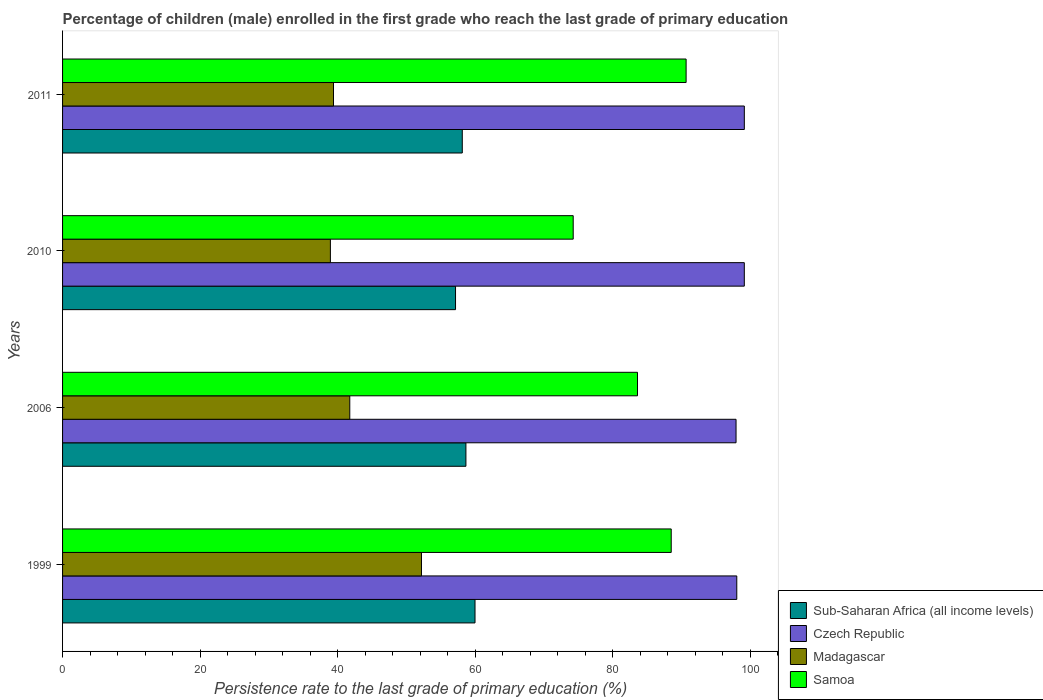How many different coloured bars are there?
Give a very brief answer. 4. How many groups of bars are there?
Provide a succinct answer. 4. Are the number of bars per tick equal to the number of legend labels?
Ensure brevity in your answer.  Yes. How many bars are there on the 3rd tick from the top?
Your answer should be compact. 4. How many bars are there on the 4th tick from the bottom?
Provide a succinct answer. 4. What is the label of the 2nd group of bars from the top?
Give a very brief answer. 2010. In how many cases, is the number of bars for a given year not equal to the number of legend labels?
Keep it short and to the point. 0. What is the persistence rate of children in Czech Republic in 2010?
Provide a short and direct response. 99.13. Across all years, what is the maximum persistence rate of children in Madagascar?
Your response must be concise. 52.19. Across all years, what is the minimum persistence rate of children in Samoa?
Your answer should be very brief. 74.25. In which year was the persistence rate of children in Sub-Saharan Africa (all income levels) minimum?
Give a very brief answer. 2010. What is the total persistence rate of children in Sub-Saharan Africa (all income levels) in the graph?
Provide a succinct answer. 233.87. What is the difference between the persistence rate of children in Madagascar in 2006 and that in 2011?
Your answer should be very brief. 2.37. What is the difference between the persistence rate of children in Madagascar in 2011 and the persistence rate of children in Czech Republic in 1999?
Your answer should be compact. -58.64. What is the average persistence rate of children in Czech Republic per year?
Offer a terse response. 98.55. In the year 2011, what is the difference between the persistence rate of children in Madagascar and persistence rate of children in Samoa?
Provide a succinct answer. -51.27. What is the ratio of the persistence rate of children in Samoa in 2006 to that in 2011?
Offer a terse response. 0.92. What is the difference between the highest and the second highest persistence rate of children in Madagascar?
Keep it short and to the point. 10.43. What is the difference between the highest and the lowest persistence rate of children in Samoa?
Provide a succinct answer. 16.42. What does the 1st bar from the top in 2006 represents?
Your answer should be compact. Samoa. What does the 2nd bar from the bottom in 1999 represents?
Your answer should be very brief. Czech Republic. Is it the case that in every year, the sum of the persistence rate of children in Madagascar and persistence rate of children in Sub-Saharan Africa (all income levels) is greater than the persistence rate of children in Samoa?
Offer a terse response. Yes. How many bars are there?
Keep it short and to the point. 16. Are all the bars in the graph horizontal?
Offer a very short reply. Yes. Does the graph contain any zero values?
Ensure brevity in your answer.  No. Where does the legend appear in the graph?
Give a very brief answer. Bottom right. How are the legend labels stacked?
Provide a short and direct response. Vertical. What is the title of the graph?
Provide a short and direct response. Percentage of children (male) enrolled in the first grade who reach the last grade of primary education. Does "Libya" appear as one of the legend labels in the graph?
Your answer should be very brief. No. What is the label or title of the X-axis?
Give a very brief answer. Persistence rate to the last grade of primary education (%). What is the Persistence rate to the last grade of primary education (%) of Sub-Saharan Africa (all income levels) in 1999?
Provide a succinct answer. 59.97. What is the Persistence rate to the last grade of primary education (%) in Czech Republic in 1999?
Offer a very short reply. 98.03. What is the Persistence rate to the last grade of primary education (%) of Madagascar in 1999?
Provide a short and direct response. 52.19. What is the Persistence rate to the last grade of primary education (%) in Samoa in 1999?
Provide a short and direct response. 88.5. What is the Persistence rate to the last grade of primary education (%) of Sub-Saharan Africa (all income levels) in 2006?
Provide a succinct answer. 58.65. What is the Persistence rate to the last grade of primary education (%) of Czech Republic in 2006?
Provide a short and direct response. 97.92. What is the Persistence rate to the last grade of primary education (%) of Madagascar in 2006?
Keep it short and to the point. 41.76. What is the Persistence rate to the last grade of primary education (%) of Samoa in 2006?
Your answer should be very brief. 83.59. What is the Persistence rate to the last grade of primary education (%) of Sub-Saharan Africa (all income levels) in 2010?
Provide a short and direct response. 57.14. What is the Persistence rate to the last grade of primary education (%) of Czech Republic in 2010?
Offer a very short reply. 99.13. What is the Persistence rate to the last grade of primary education (%) of Madagascar in 2010?
Keep it short and to the point. 38.94. What is the Persistence rate to the last grade of primary education (%) of Samoa in 2010?
Your response must be concise. 74.25. What is the Persistence rate to the last grade of primary education (%) of Sub-Saharan Africa (all income levels) in 2011?
Give a very brief answer. 58.12. What is the Persistence rate to the last grade of primary education (%) of Czech Republic in 2011?
Offer a terse response. 99.13. What is the Persistence rate to the last grade of primary education (%) in Madagascar in 2011?
Make the answer very short. 39.39. What is the Persistence rate to the last grade of primary education (%) of Samoa in 2011?
Your response must be concise. 90.66. Across all years, what is the maximum Persistence rate to the last grade of primary education (%) in Sub-Saharan Africa (all income levels)?
Your answer should be very brief. 59.97. Across all years, what is the maximum Persistence rate to the last grade of primary education (%) of Czech Republic?
Offer a terse response. 99.13. Across all years, what is the maximum Persistence rate to the last grade of primary education (%) in Madagascar?
Your answer should be very brief. 52.19. Across all years, what is the maximum Persistence rate to the last grade of primary education (%) of Samoa?
Give a very brief answer. 90.66. Across all years, what is the minimum Persistence rate to the last grade of primary education (%) of Sub-Saharan Africa (all income levels)?
Make the answer very short. 57.14. Across all years, what is the minimum Persistence rate to the last grade of primary education (%) in Czech Republic?
Give a very brief answer. 97.92. Across all years, what is the minimum Persistence rate to the last grade of primary education (%) of Madagascar?
Offer a very short reply. 38.94. Across all years, what is the minimum Persistence rate to the last grade of primary education (%) in Samoa?
Your response must be concise. 74.25. What is the total Persistence rate to the last grade of primary education (%) in Sub-Saharan Africa (all income levels) in the graph?
Ensure brevity in your answer.  233.87. What is the total Persistence rate to the last grade of primary education (%) in Czech Republic in the graph?
Make the answer very short. 394.2. What is the total Persistence rate to the last grade of primary education (%) of Madagascar in the graph?
Make the answer very short. 172.28. What is the total Persistence rate to the last grade of primary education (%) of Samoa in the graph?
Your answer should be very brief. 337. What is the difference between the Persistence rate to the last grade of primary education (%) of Sub-Saharan Africa (all income levels) in 1999 and that in 2006?
Your response must be concise. 1.32. What is the difference between the Persistence rate to the last grade of primary education (%) in Czech Republic in 1999 and that in 2006?
Your response must be concise. 0.11. What is the difference between the Persistence rate to the last grade of primary education (%) in Madagascar in 1999 and that in 2006?
Give a very brief answer. 10.43. What is the difference between the Persistence rate to the last grade of primary education (%) of Samoa in 1999 and that in 2006?
Provide a short and direct response. 4.9. What is the difference between the Persistence rate to the last grade of primary education (%) of Sub-Saharan Africa (all income levels) in 1999 and that in 2010?
Ensure brevity in your answer.  2.83. What is the difference between the Persistence rate to the last grade of primary education (%) in Czech Republic in 1999 and that in 2010?
Keep it short and to the point. -1.1. What is the difference between the Persistence rate to the last grade of primary education (%) in Madagascar in 1999 and that in 2010?
Your answer should be very brief. 13.25. What is the difference between the Persistence rate to the last grade of primary education (%) of Samoa in 1999 and that in 2010?
Make the answer very short. 14.25. What is the difference between the Persistence rate to the last grade of primary education (%) in Sub-Saharan Africa (all income levels) in 1999 and that in 2011?
Provide a short and direct response. 1.85. What is the difference between the Persistence rate to the last grade of primary education (%) in Czech Republic in 1999 and that in 2011?
Provide a succinct answer. -1.1. What is the difference between the Persistence rate to the last grade of primary education (%) of Madagascar in 1999 and that in 2011?
Offer a terse response. 12.79. What is the difference between the Persistence rate to the last grade of primary education (%) in Samoa in 1999 and that in 2011?
Your answer should be very brief. -2.17. What is the difference between the Persistence rate to the last grade of primary education (%) in Sub-Saharan Africa (all income levels) in 2006 and that in 2010?
Give a very brief answer. 1.51. What is the difference between the Persistence rate to the last grade of primary education (%) of Czech Republic in 2006 and that in 2010?
Provide a short and direct response. -1.2. What is the difference between the Persistence rate to the last grade of primary education (%) in Madagascar in 2006 and that in 2010?
Your answer should be very brief. 2.82. What is the difference between the Persistence rate to the last grade of primary education (%) of Samoa in 2006 and that in 2010?
Your answer should be compact. 9.35. What is the difference between the Persistence rate to the last grade of primary education (%) of Sub-Saharan Africa (all income levels) in 2006 and that in 2011?
Your answer should be compact. 0.53. What is the difference between the Persistence rate to the last grade of primary education (%) of Czech Republic in 2006 and that in 2011?
Ensure brevity in your answer.  -1.2. What is the difference between the Persistence rate to the last grade of primary education (%) in Madagascar in 2006 and that in 2011?
Your answer should be very brief. 2.37. What is the difference between the Persistence rate to the last grade of primary education (%) of Samoa in 2006 and that in 2011?
Offer a terse response. -7.07. What is the difference between the Persistence rate to the last grade of primary education (%) in Sub-Saharan Africa (all income levels) in 2010 and that in 2011?
Ensure brevity in your answer.  -0.98. What is the difference between the Persistence rate to the last grade of primary education (%) in Czech Republic in 2010 and that in 2011?
Your answer should be compact. -0. What is the difference between the Persistence rate to the last grade of primary education (%) of Madagascar in 2010 and that in 2011?
Provide a short and direct response. -0.45. What is the difference between the Persistence rate to the last grade of primary education (%) of Samoa in 2010 and that in 2011?
Offer a terse response. -16.42. What is the difference between the Persistence rate to the last grade of primary education (%) of Sub-Saharan Africa (all income levels) in 1999 and the Persistence rate to the last grade of primary education (%) of Czech Republic in 2006?
Keep it short and to the point. -37.95. What is the difference between the Persistence rate to the last grade of primary education (%) in Sub-Saharan Africa (all income levels) in 1999 and the Persistence rate to the last grade of primary education (%) in Madagascar in 2006?
Offer a very short reply. 18.21. What is the difference between the Persistence rate to the last grade of primary education (%) in Sub-Saharan Africa (all income levels) in 1999 and the Persistence rate to the last grade of primary education (%) in Samoa in 2006?
Provide a short and direct response. -23.63. What is the difference between the Persistence rate to the last grade of primary education (%) of Czech Republic in 1999 and the Persistence rate to the last grade of primary education (%) of Madagascar in 2006?
Make the answer very short. 56.27. What is the difference between the Persistence rate to the last grade of primary education (%) in Czech Republic in 1999 and the Persistence rate to the last grade of primary education (%) in Samoa in 2006?
Offer a very short reply. 14.44. What is the difference between the Persistence rate to the last grade of primary education (%) in Madagascar in 1999 and the Persistence rate to the last grade of primary education (%) in Samoa in 2006?
Keep it short and to the point. -31.41. What is the difference between the Persistence rate to the last grade of primary education (%) of Sub-Saharan Africa (all income levels) in 1999 and the Persistence rate to the last grade of primary education (%) of Czech Republic in 2010?
Provide a succinct answer. -39.16. What is the difference between the Persistence rate to the last grade of primary education (%) of Sub-Saharan Africa (all income levels) in 1999 and the Persistence rate to the last grade of primary education (%) of Madagascar in 2010?
Keep it short and to the point. 21.03. What is the difference between the Persistence rate to the last grade of primary education (%) in Sub-Saharan Africa (all income levels) in 1999 and the Persistence rate to the last grade of primary education (%) in Samoa in 2010?
Provide a short and direct response. -14.28. What is the difference between the Persistence rate to the last grade of primary education (%) of Czech Republic in 1999 and the Persistence rate to the last grade of primary education (%) of Madagascar in 2010?
Your answer should be very brief. 59.09. What is the difference between the Persistence rate to the last grade of primary education (%) of Czech Republic in 1999 and the Persistence rate to the last grade of primary education (%) of Samoa in 2010?
Your answer should be compact. 23.78. What is the difference between the Persistence rate to the last grade of primary education (%) of Madagascar in 1999 and the Persistence rate to the last grade of primary education (%) of Samoa in 2010?
Make the answer very short. -22.06. What is the difference between the Persistence rate to the last grade of primary education (%) of Sub-Saharan Africa (all income levels) in 1999 and the Persistence rate to the last grade of primary education (%) of Czech Republic in 2011?
Your answer should be very brief. -39.16. What is the difference between the Persistence rate to the last grade of primary education (%) in Sub-Saharan Africa (all income levels) in 1999 and the Persistence rate to the last grade of primary education (%) in Madagascar in 2011?
Your answer should be very brief. 20.58. What is the difference between the Persistence rate to the last grade of primary education (%) in Sub-Saharan Africa (all income levels) in 1999 and the Persistence rate to the last grade of primary education (%) in Samoa in 2011?
Offer a terse response. -30.69. What is the difference between the Persistence rate to the last grade of primary education (%) in Czech Republic in 1999 and the Persistence rate to the last grade of primary education (%) in Madagascar in 2011?
Provide a short and direct response. 58.64. What is the difference between the Persistence rate to the last grade of primary education (%) of Czech Republic in 1999 and the Persistence rate to the last grade of primary education (%) of Samoa in 2011?
Your answer should be very brief. 7.37. What is the difference between the Persistence rate to the last grade of primary education (%) of Madagascar in 1999 and the Persistence rate to the last grade of primary education (%) of Samoa in 2011?
Ensure brevity in your answer.  -38.48. What is the difference between the Persistence rate to the last grade of primary education (%) of Sub-Saharan Africa (all income levels) in 2006 and the Persistence rate to the last grade of primary education (%) of Czech Republic in 2010?
Make the answer very short. -40.48. What is the difference between the Persistence rate to the last grade of primary education (%) of Sub-Saharan Africa (all income levels) in 2006 and the Persistence rate to the last grade of primary education (%) of Madagascar in 2010?
Provide a short and direct response. 19.71. What is the difference between the Persistence rate to the last grade of primary education (%) in Sub-Saharan Africa (all income levels) in 2006 and the Persistence rate to the last grade of primary education (%) in Samoa in 2010?
Your answer should be compact. -15.6. What is the difference between the Persistence rate to the last grade of primary education (%) of Czech Republic in 2006 and the Persistence rate to the last grade of primary education (%) of Madagascar in 2010?
Ensure brevity in your answer.  58.98. What is the difference between the Persistence rate to the last grade of primary education (%) of Czech Republic in 2006 and the Persistence rate to the last grade of primary education (%) of Samoa in 2010?
Provide a short and direct response. 23.68. What is the difference between the Persistence rate to the last grade of primary education (%) of Madagascar in 2006 and the Persistence rate to the last grade of primary education (%) of Samoa in 2010?
Make the answer very short. -32.49. What is the difference between the Persistence rate to the last grade of primary education (%) of Sub-Saharan Africa (all income levels) in 2006 and the Persistence rate to the last grade of primary education (%) of Czech Republic in 2011?
Your response must be concise. -40.48. What is the difference between the Persistence rate to the last grade of primary education (%) of Sub-Saharan Africa (all income levels) in 2006 and the Persistence rate to the last grade of primary education (%) of Madagascar in 2011?
Ensure brevity in your answer.  19.26. What is the difference between the Persistence rate to the last grade of primary education (%) in Sub-Saharan Africa (all income levels) in 2006 and the Persistence rate to the last grade of primary education (%) in Samoa in 2011?
Keep it short and to the point. -32.02. What is the difference between the Persistence rate to the last grade of primary education (%) in Czech Republic in 2006 and the Persistence rate to the last grade of primary education (%) in Madagascar in 2011?
Your answer should be compact. 58.53. What is the difference between the Persistence rate to the last grade of primary education (%) in Czech Republic in 2006 and the Persistence rate to the last grade of primary education (%) in Samoa in 2011?
Offer a very short reply. 7.26. What is the difference between the Persistence rate to the last grade of primary education (%) in Madagascar in 2006 and the Persistence rate to the last grade of primary education (%) in Samoa in 2011?
Keep it short and to the point. -48.9. What is the difference between the Persistence rate to the last grade of primary education (%) in Sub-Saharan Africa (all income levels) in 2010 and the Persistence rate to the last grade of primary education (%) in Czech Republic in 2011?
Provide a short and direct response. -41.99. What is the difference between the Persistence rate to the last grade of primary education (%) in Sub-Saharan Africa (all income levels) in 2010 and the Persistence rate to the last grade of primary education (%) in Madagascar in 2011?
Provide a short and direct response. 17.74. What is the difference between the Persistence rate to the last grade of primary education (%) in Sub-Saharan Africa (all income levels) in 2010 and the Persistence rate to the last grade of primary education (%) in Samoa in 2011?
Make the answer very short. -33.53. What is the difference between the Persistence rate to the last grade of primary education (%) of Czech Republic in 2010 and the Persistence rate to the last grade of primary education (%) of Madagascar in 2011?
Your answer should be very brief. 59.73. What is the difference between the Persistence rate to the last grade of primary education (%) of Czech Republic in 2010 and the Persistence rate to the last grade of primary education (%) of Samoa in 2011?
Make the answer very short. 8.46. What is the difference between the Persistence rate to the last grade of primary education (%) of Madagascar in 2010 and the Persistence rate to the last grade of primary education (%) of Samoa in 2011?
Your response must be concise. -51.72. What is the average Persistence rate to the last grade of primary education (%) of Sub-Saharan Africa (all income levels) per year?
Give a very brief answer. 58.47. What is the average Persistence rate to the last grade of primary education (%) of Czech Republic per year?
Your response must be concise. 98.55. What is the average Persistence rate to the last grade of primary education (%) in Madagascar per year?
Offer a terse response. 43.07. What is the average Persistence rate to the last grade of primary education (%) of Samoa per year?
Keep it short and to the point. 84.25. In the year 1999, what is the difference between the Persistence rate to the last grade of primary education (%) of Sub-Saharan Africa (all income levels) and Persistence rate to the last grade of primary education (%) of Czech Republic?
Your answer should be very brief. -38.06. In the year 1999, what is the difference between the Persistence rate to the last grade of primary education (%) in Sub-Saharan Africa (all income levels) and Persistence rate to the last grade of primary education (%) in Madagascar?
Offer a very short reply. 7.78. In the year 1999, what is the difference between the Persistence rate to the last grade of primary education (%) of Sub-Saharan Africa (all income levels) and Persistence rate to the last grade of primary education (%) of Samoa?
Give a very brief answer. -28.53. In the year 1999, what is the difference between the Persistence rate to the last grade of primary education (%) in Czech Republic and Persistence rate to the last grade of primary education (%) in Madagascar?
Ensure brevity in your answer.  45.84. In the year 1999, what is the difference between the Persistence rate to the last grade of primary education (%) in Czech Republic and Persistence rate to the last grade of primary education (%) in Samoa?
Your response must be concise. 9.53. In the year 1999, what is the difference between the Persistence rate to the last grade of primary education (%) of Madagascar and Persistence rate to the last grade of primary education (%) of Samoa?
Offer a terse response. -36.31. In the year 2006, what is the difference between the Persistence rate to the last grade of primary education (%) in Sub-Saharan Africa (all income levels) and Persistence rate to the last grade of primary education (%) in Czech Republic?
Keep it short and to the point. -39.28. In the year 2006, what is the difference between the Persistence rate to the last grade of primary education (%) in Sub-Saharan Africa (all income levels) and Persistence rate to the last grade of primary education (%) in Madagascar?
Your answer should be compact. 16.89. In the year 2006, what is the difference between the Persistence rate to the last grade of primary education (%) in Sub-Saharan Africa (all income levels) and Persistence rate to the last grade of primary education (%) in Samoa?
Give a very brief answer. -24.95. In the year 2006, what is the difference between the Persistence rate to the last grade of primary education (%) of Czech Republic and Persistence rate to the last grade of primary education (%) of Madagascar?
Give a very brief answer. 56.16. In the year 2006, what is the difference between the Persistence rate to the last grade of primary education (%) of Czech Republic and Persistence rate to the last grade of primary education (%) of Samoa?
Make the answer very short. 14.33. In the year 2006, what is the difference between the Persistence rate to the last grade of primary education (%) of Madagascar and Persistence rate to the last grade of primary education (%) of Samoa?
Provide a short and direct response. -41.83. In the year 2010, what is the difference between the Persistence rate to the last grade of primary education (%) in Sub-Saharan Africa (all income levels) and Persistence rate to the last grade of primary education (%) in Czech Republic?
Keep it short and to the point. -41.99. In the year 2010, what is the difference between the Persistence rate to the last grade of primary education (%) in Sub-Saharan Africa (all income levels) and Persistence rate to the last grade of primary education (%) in Madagascar?
Keep it short and to the point. 18.2. In the year 2010, what is the difference between the Persistence rate to the last grade of primary education (%) of Sub-Saharan Africa (all income levels) and Persistence rate to the last grade of primary education (%) of Samoa?
Keep it short and to the point. -17.11. In the year 2010, what is the difference between the Persistence rate to the last grade of primary education (%) of Czech Republic and Persistence rate to the last grade of primary education (%) of Madagascar?
Keep it short and to the point. 60.18. In the year 2010, what is the difference between the Persistence rate to the last grade of primary education (%) of Czech Republic and Persistence rate to the last grade of primary education (%) of Samoa?
Your answer should be very brief. 24.88. In the year 2010, what is the difference between the Persistence rate to the last grade of primary education (%) of Madagascar and Persistence rate to the last grade of primary education (%) of Samoa?
Give a very brief answer. -35.3. In the year 2011, what is the difference between the Persistence rate to the last grade of primary education (%) of Sub-Saharan Africa (all income levels) and Persistence rate to the last grade of primary education (%) of Czech Republic?
Provide a short and direct response. -41.01. In the year 2011, what is the difference between the Persistence rate to the last grade of primary education (%) of Sub-Saharan Africa (all income levels) and Persistence rate to the last grade of primary education (%) of Madagascar?
Provide a succinct answer. 18.73. In the year 2011, what is the difference between the Persistence rate to the last grade of primary education (%) in Sub-Saharan Africa (all income levels) and Persistence rate to the last grade of primary education (%) in Samoa?
Ensure brevity in your answer.  -32.54. In the year 2011, what is the difference between the Persistence rate to the last grade of primary education (%) in Czech Republic and Persistence rate to the last grade of primary education (%) in Madagascar?
Your response must be concise. 59.73. In the year 2011, what is the difference between the Persistence rate to the last grade of primary education (%) of Czech Republic and Persistence rate to the last grade of primary education (%) of Samoa?
Keep it short and to the point. 8.46. In the year 2011, what is the difference between the Persistence rate to the last grade of primary education (%) in Madagascar and Persistence rate to the last grade of primary education (%) in Samoa?
Keep it short and to the point. -51.27. What is the ratio of the Persistence rate to the last grade of primary education (%) of Sub-Saharan Africa (all income levels) in 1999 to that in 2006?
Your answer should be compact. 1.02. What is the ratio of the Persistence rate to the last grade of primary education (%) in Madagascar in 1999 to that in 2006?
Offer a terse response. 1.25. What is the ratio of the Persistence rate to the last grade of primary education (%) of Samoa in 1999 to that in 2006?
Provide a short and direct response. 1.06. What is the ratio of the Persistence rate to the last grade of primary education (%) of Sub-Saharan Africa (all income levels) in 1999 to that in 2010?
Give a very brief answer. 1.05. What is the ratio of the Persistence rate to the last grade of primary education (%) in Madagascar in 1999 to that in 2010?
Your answer should be compact. 1.34. What is the ratio of the Persistence rate to the last grade of primary education (%) of Samoa in 1999 to that in 2010?
Your answer should be very brief. 1.19. What is the ratio of the Persistence rate to the last grade of primary education (%) of Sub-Saharan Africa (all income levels) in 1999 to that in 2011?
Make the answer very short. 1.03. What is the ratio of the Persistence rate to the last grade of primary education (%) of Czech Republic in 1999 to that in 2011?
Offer a terse response. 0.99. What is the ratio of the Persistence rate to the last grade of primary education (%) in Madagascar in 1999 to that in 2011?
Your answer should be compact. 1.32. What is the ratio of the Persistence rate to the last grade of primary education (%) of Samoa in 1999 to that in 2011?
Keep it short and to the point. 0.98. What is the ratio of the Persistence rate to the last grade of primary education (%) of Sub-Saharan Africa (all income levels) in 2006 to that in 2010?
Your answer should be compact. 1.03. What is the ratio of the Persistence rate to the last grade of primary education (%) of Czech Republic in 2006 to that in 2010?
Provide a short and direct response. 0.99. What is the ratio of the Persistence rate to the last grade of primary education (%) of Madagascar in 2006 to that in 2010?
Offer a terse response. 1.07. What is the ratio of the Persistence rate to the last grade of primary education (%) in Samoa in 2006 to that in 2010?
Your response must be concise. 1.13. What is the ratio of the Persistence rate to the last grade of primary education (%) in Sub-Saharan Africa (all income levels) in 2006 to that in 2011?
Your answer should be very brief. 1.01. What is the ratio of the Persistence rate to the last grade of primary education (%) of Czech Republic in 2006 to that in 2011?
Make the answer very short. 0.99. What is the ratio of the Persistence rate to the last grade of primary education (%) in Madagascar in 2006 to that in 2011?
Your answer should be very brief. 1.06. What is the ratio of the Persistence rate to the last grade of primary education (%) in Samoa in 2006 to that in 2011?
Provide a short and direct response. 0.92. What is the ratio of the Persistence rate to the last grade of primary education (%) in Sub-Saharan Africa (all income levels) in 2010 to that in 2011?
Give a very brief answer. 0.98. What is the ratio of the Persistence rate to the last grade of primary education (%) in Czech Republic in 2010 to that in 2011?
Give a very brief answer. 1. What is the ratio of the Persistence rate to the last grade of primary education (%) in Madagascar in 2010 to that in 2011?
Make the answer very short. 0.99. What is the ratio of the Persistence rate to the last grade of primary education (%) of Samoa in 2010 to that in 2011?
Your answer should be compact. 0.82. What is the difference between the highest and the second highest Persistence rate to the last grade of primary education (%) of Sub-Saharan Africa (all income levels)?
Your answer should be very brief. 1.32. What is the difference between the highest and the second highest Persistence rate to the last grade of primary education (%) in Czech Republic?
Your response must be concise. 0. What is the difference between the highest and the second highest Persistence rate to the last grade of primary education (%) of Madagascar?
Your answer should be very brief. 10.43. What is the difference between the highest and the second highest Persistence rate to the last grade of primary education (%) in Samoa?
Make the answer very short. 2.17. What is the difference between the highest and the lowest Persistence rate to the last grade of primary education (%) of Sub-Saharan Africa (all income levels)?
Your answer should be compact. 2.83. What is the difference between the highest and the lowest Persistence rate to the last grade of primary education (%) in Czech Republic?
Give a very brief answer. 1.2. What is the difference between the highest and the lowest Persistence rate to the last grade of primary education (%) of Madagascar?
Keep it short and to the point. 13.25. What is the difference between the highest and the lowest Persistence rate to the last grade of primary education (%) of Samoa?
Provide a succinct answer. 16.42. 